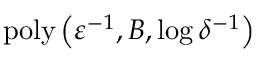Convert formula to latex. <formula><loc_0><loc_0><loc_500><loc_500>p o l y \left ( \varepsilon ^ { - 1 } , B , \log \delta ^ { - 1 } \right )</formula> 